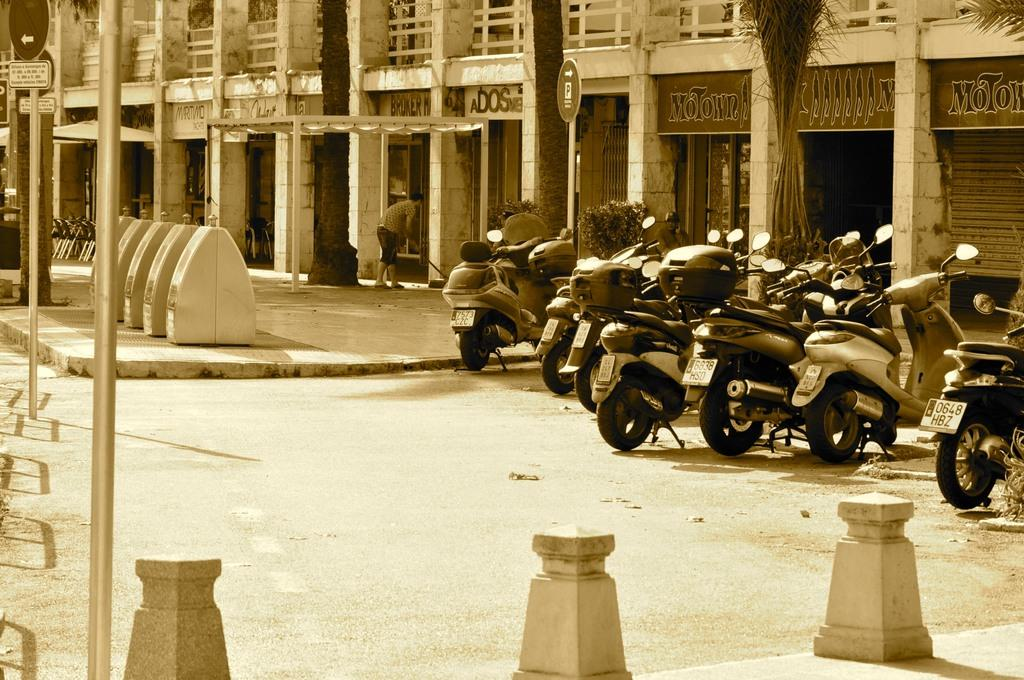What type of vehicles can be seen in the image? There are many motorbikes in the image. What structures are present in the image? There are poles and a building in the image. Who or what is in front of the person in the image? There is a building and plants in front of the person in the image. Can you describe the person in the image? There is a person standing in the image. What type of fruit is being cared for by the person in the image? There is no fruit present in the image, nor is there any indication that the person is caring for any fruit. 